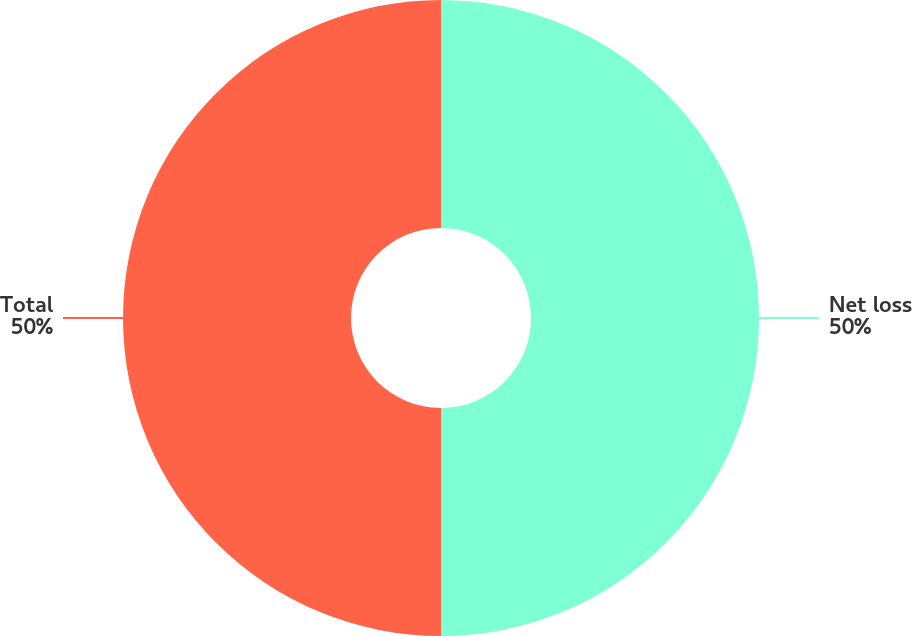<chart> <loc_0><loc_0><loc_500><loc_500><pie_chart><fcel>Net loss<fcel>Total<nl><fcel>50.0%<fcel>50.0%<nl></chart> 